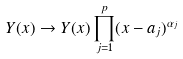<formula> <loc_0><loc_0><loc_500><loc_500>Y ( x ) \to Y ( x ) \prod _ { j = 1 } ^ { p } ( x - a _ { j } ) ^ { \alpha _ { j } }</formula> 